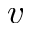Convert formula to latex. <formula><loc_0><loc_0><loc_500><loc_500>v</formula> 